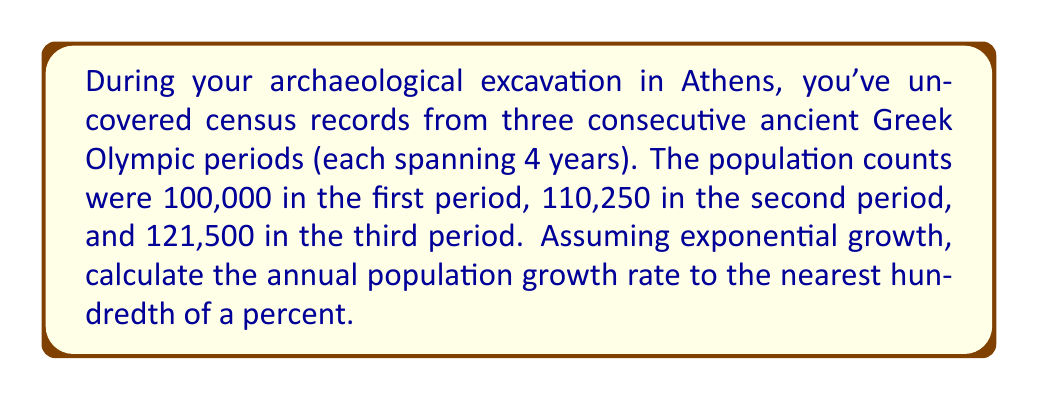What is the answer to this math problem? Let's approach this step-by-step:

1) First, we need to recognize that we have three data points over a span of 8 years (two Olympic periods).

2) The formula for exponential growth is:

   $$P_t = P_0 * (1 + r)^t$$

   Where:
   $P_t$ is the final population
   $P_0$ is the initial population
   $r$ is the annual growth rate
   $t$ is the number of years

3) We can use the first and last data points:
   $P_0 = 100,000$
   $P_t = 121,500$
   $t = 8$ years

4) Plugging these into our formula:

   $$121,500 = 100,000 * (1 + r)^8$$

5) Dividing both sides by 100,000:

   $$1.215 = (1 + r)^8$$

6) Taking the 8th root of both sides:

   $$\sqrt[8]{1.215} = 1 + r$$

7) Subtracting 1 from both sides:

   $$\sqrt[8]{1.215} - 1 = r$$

8) Calculate this value:

   $$r \approx 0.0246$$

9) Convert to a percentage by multiplying by 100:

   $$r \approx 2.46\%$$

10) Rounding to the nearest hundredth of a percent:

    $$r \approx 2.46\%$$
Answer: 2.46% 